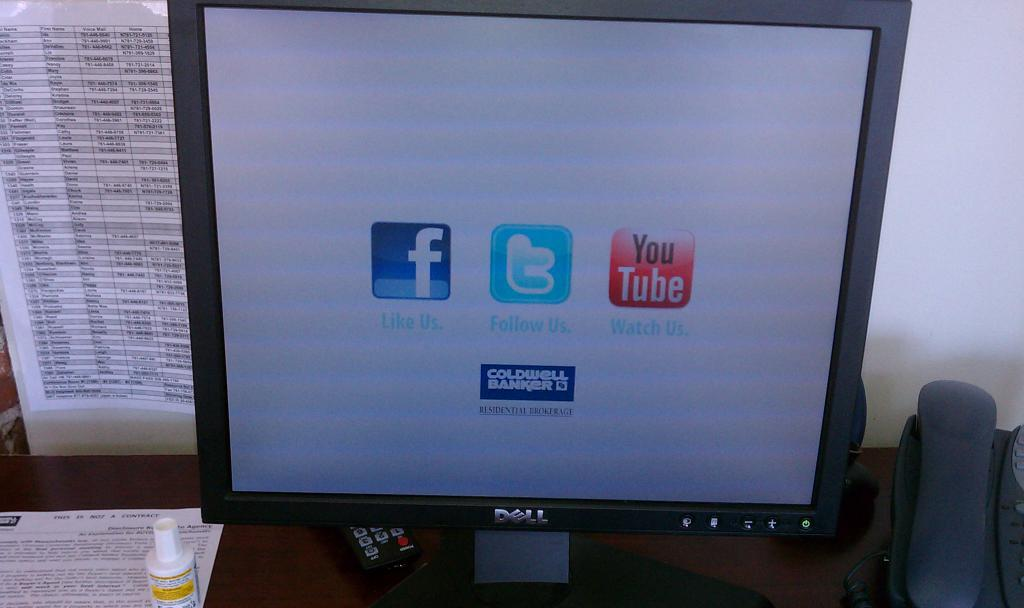<image>
Provide a brief description of the given image. A Dell computer screen is open to a white screen with icons for Facebook, Twitter, YouTube, and Caldwell Banker under them. 